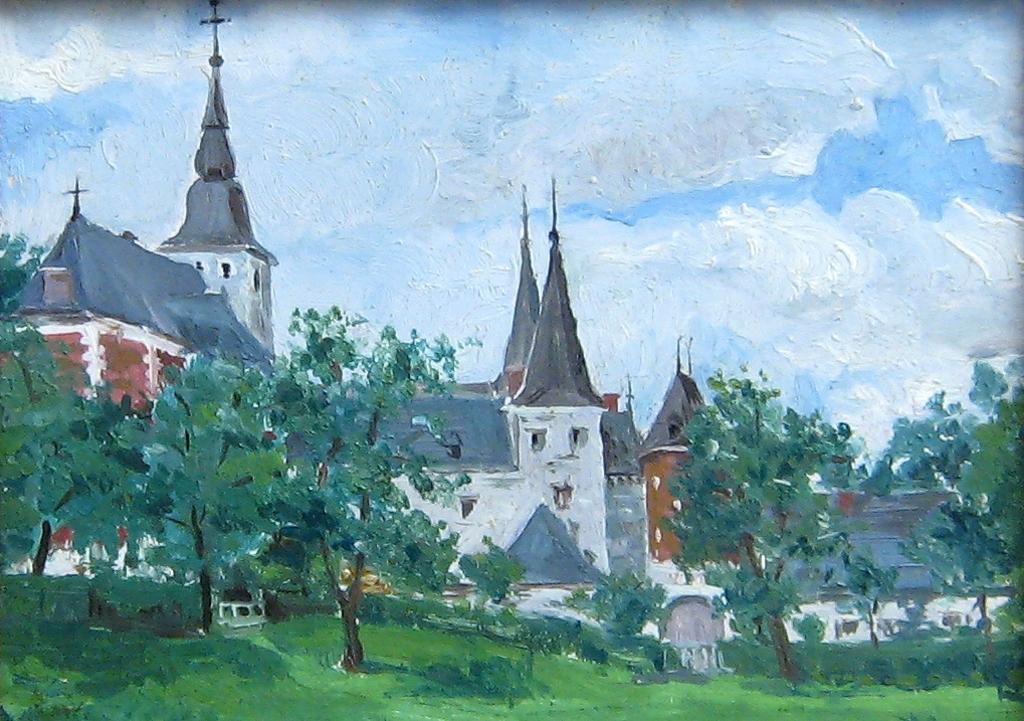Please provide a concise description of this image. This image consists of a painting. In the middle there are houses, trees, grass, sky and clouds. 